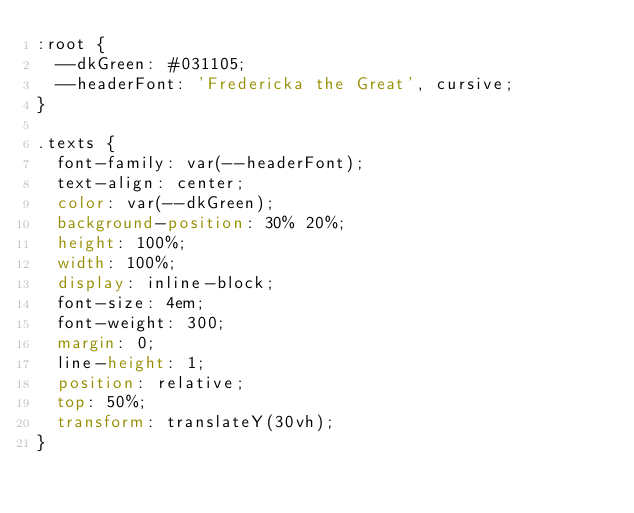Convert code to text. <code><loc_0><loc_0><loc_500><loc_500><_CSS_>:root {
  --dkGreen: #031105;
  --headerFont: 'Fredericka the Great', cursive;
}

.texts {
  font-family: var(--headerFont);
  text-align: center;
  color: var(--dkGreen);
  background-position: 30% 20%;
  height: 100%;
  width: 100%;
  display: inline-block;
  font-size: 4em;
  font-weight: 300;
  margin: 0;
  line-height: 1;
  position: relative;
  top: 50%;
  transform: translateY(30vh);
}
</code> 